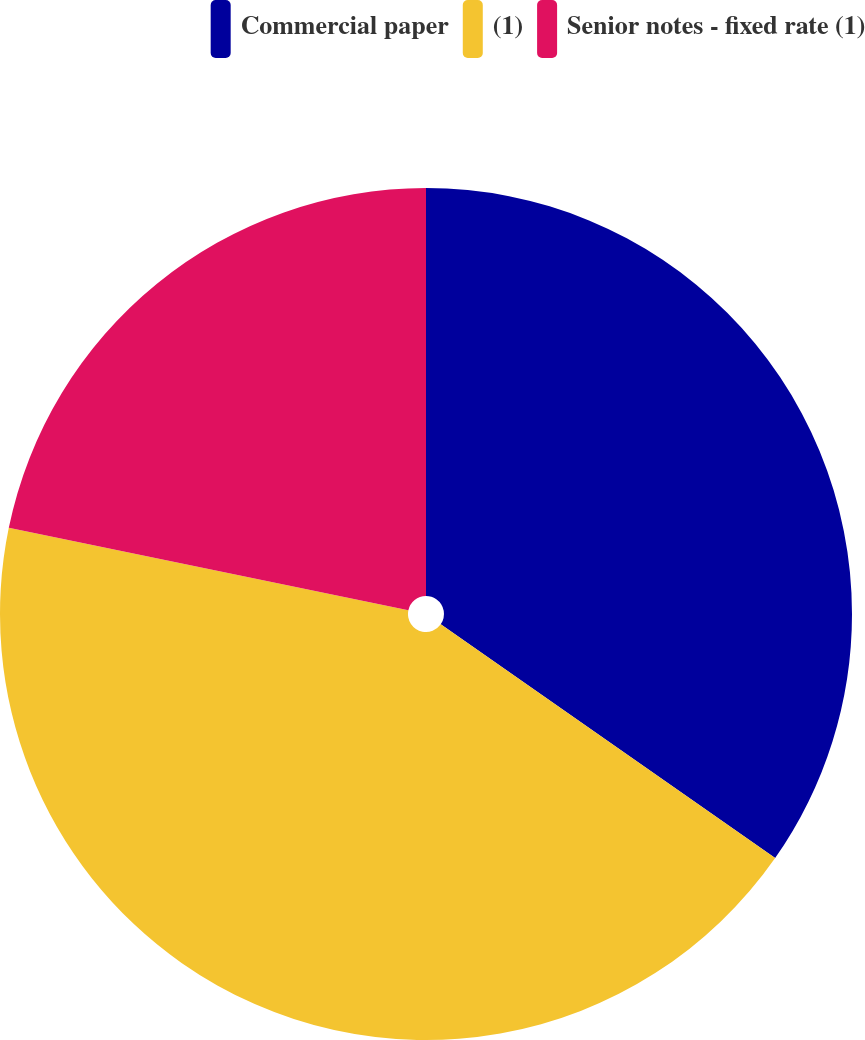<chart> <loc_0><loc_0><loc_500><loc_500><pie_chart><fcel>Commercial paper<fcel>(1)<fcel>Senior notes - fixed rate (1)<nl><fcel>34.71%<fcel>43.53%<fcel>21.76%<nl></chart> 